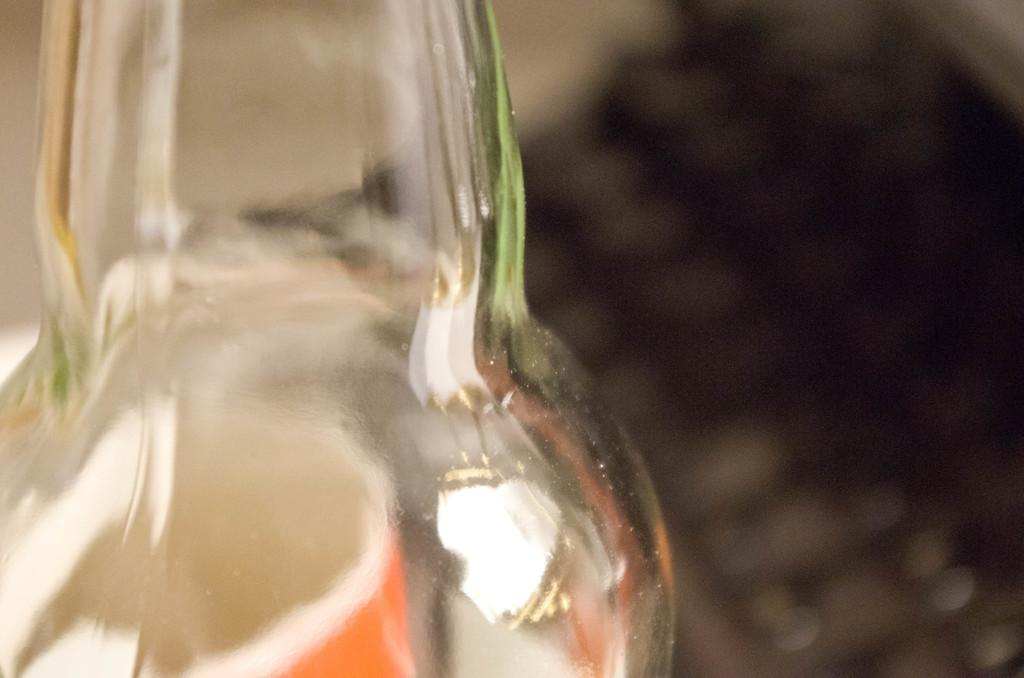What type of container is visible in the image? There is a transparent glass bottle in the image. What type of fuel is used for the bottle's voyage in the image? There is no indication of a voyage or fuel in the image, as it only features a transparent glass bottle. 